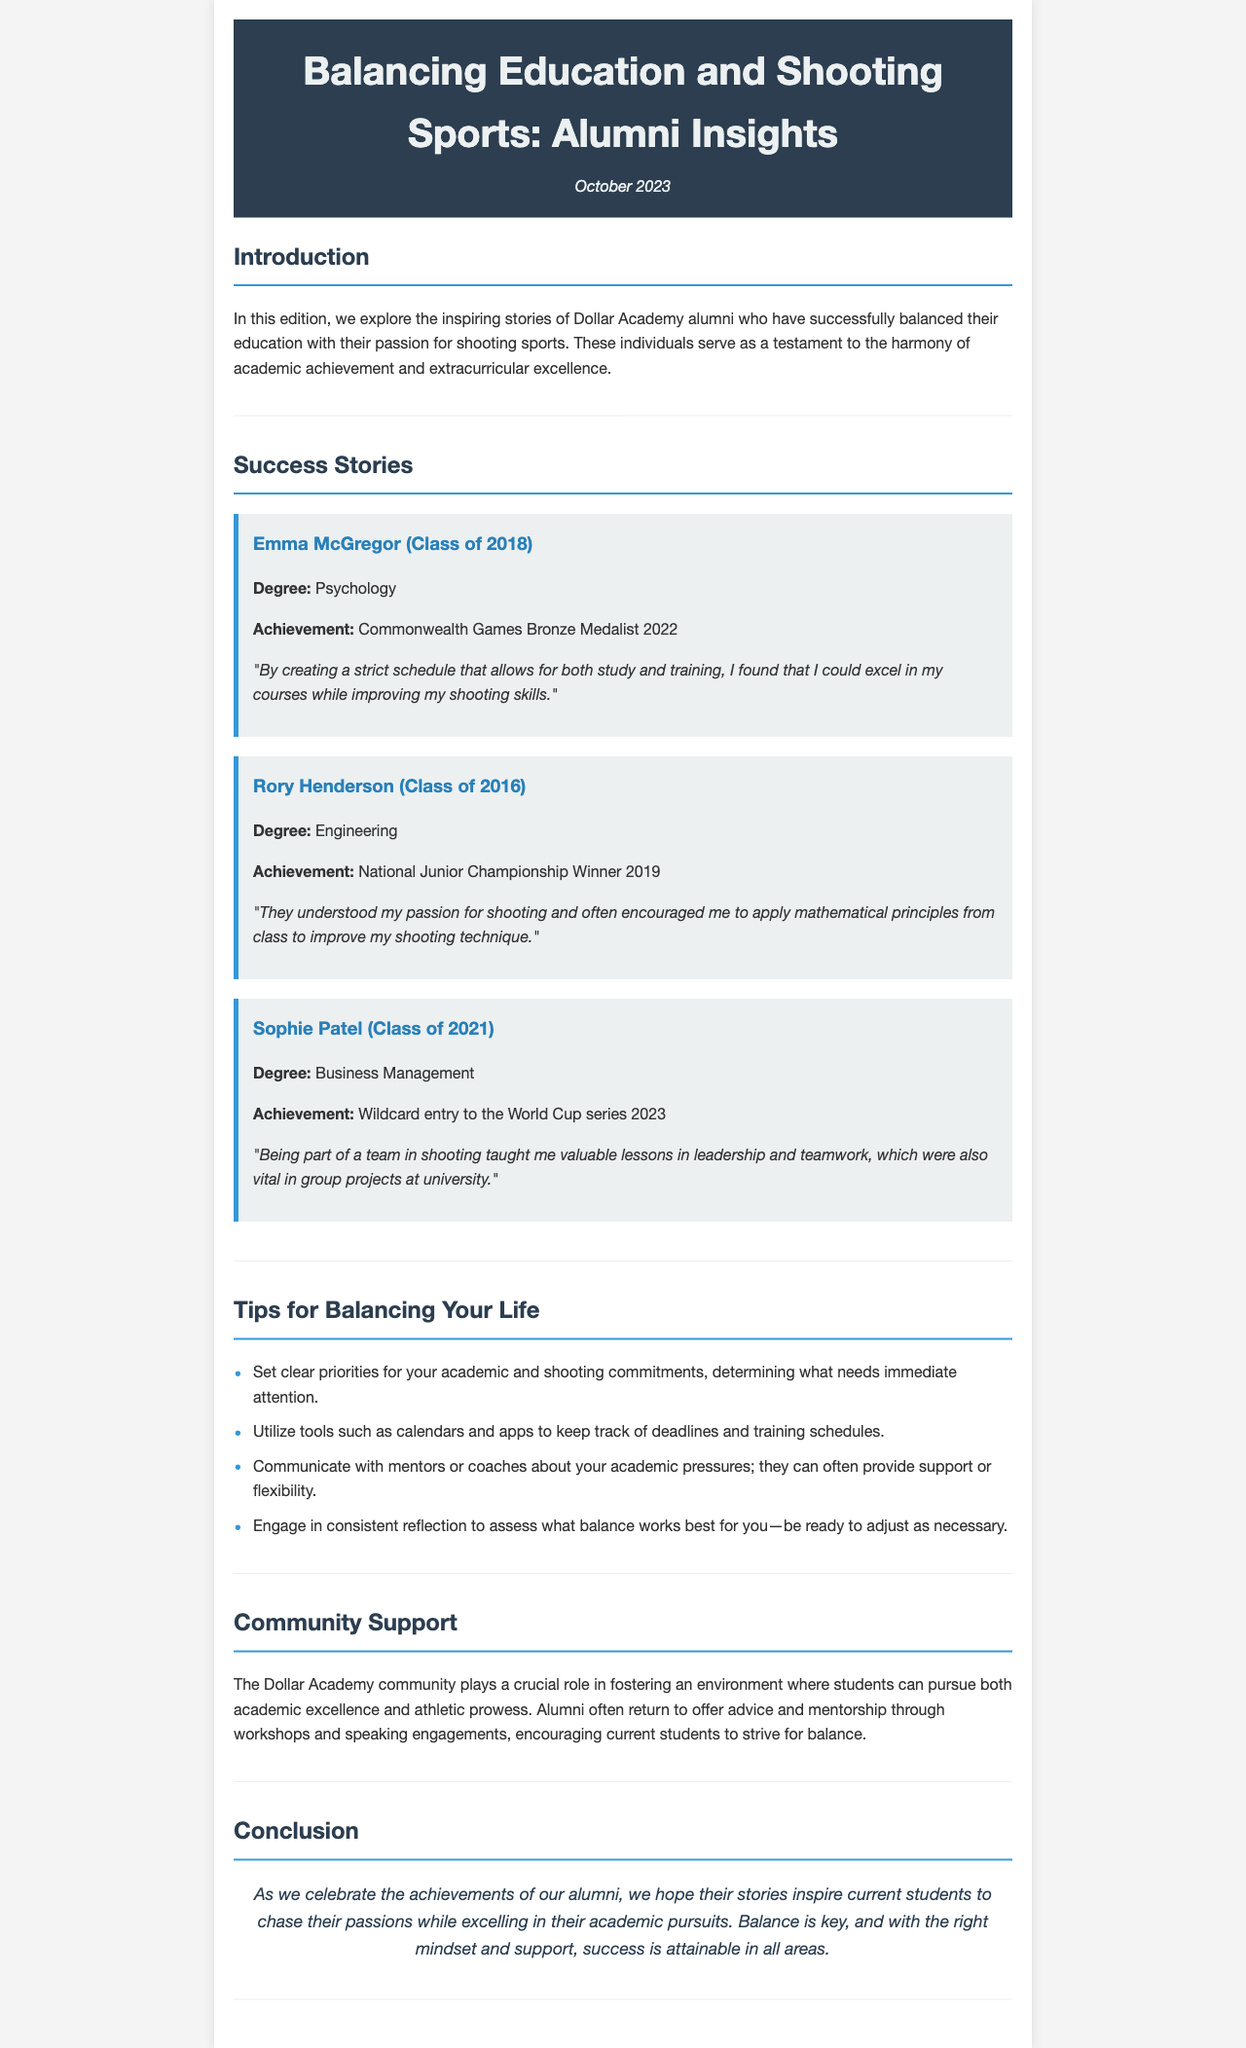What is the date of the newsletter? The newsletter is dated October 2023, as indicated in the header section.
Answer: October 2023 Who is the Commonwealth Games Bronze Medalist mentioned? Emma McGregor is identified as the Commonwealth Games Bronze Medalist in 2022 in the success stories section.
Answer: Emma McGregor What degree did Rory Henderson pursue? Rory Henderson's degree is listed as Engineering in his story.
Answer: Engineering In which year did Sophie Patel qualify for the World Cup series? Sophie Patel's wildcard entry to the World Cup series occurred in 2023, as stated in her achievement.
Answer: 2023 What key advice is given for balancing academic and shooting commitments? The document suggests setting clear priorities for commitments, highlighting the importance of addressing immediate tasks.
Answer: Set clear priorities Which community plays a crucial role in supporting students balancing education and sports? The Dollar Academy community is described as a supportive environment for students navigating academics and athletics.
Answer: Dollar Academy What valuable lesson did Sophie Patel learn from being part of a shooting team? She noted that teamwork in shooting taught her valuable lessons that were vital in group projects at university.
Answer: Leadership and teamwork How did Rory Henderson apply his mathematics knowledge in shooting? Rory mentioned that his teachers encouraged applying mathematical principles from class to enhance his shooting technique.
Answer: Mathematical principles What is the main theme of the newsletter? The newsletter focuses on the balance between education and shooting sports, showcasing alumni achievements in both areas.
Answer: Balance between education and shooting sports 